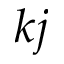<formula> <loc_0><loc_0><loc_500><loc_500>k j</formula> 